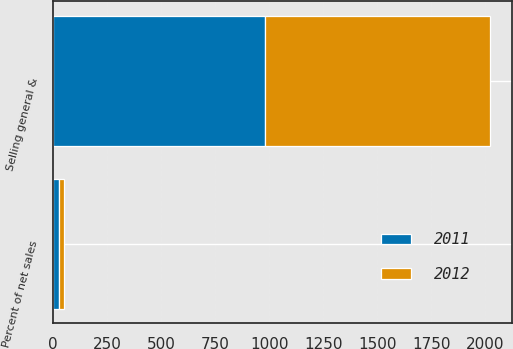Convert chart to OTSL. <chart><loc_0><loc_0><loc_500><loc_500><stacked_bar_chart><ecel><fcel>Selling general &<fcel>Percent of net sales<nl><fcel>2012<fcel>1039.5<fcel>25.9<nl><fcel>2011<fcel>982.2<fcel>26.6<nl></chart> 